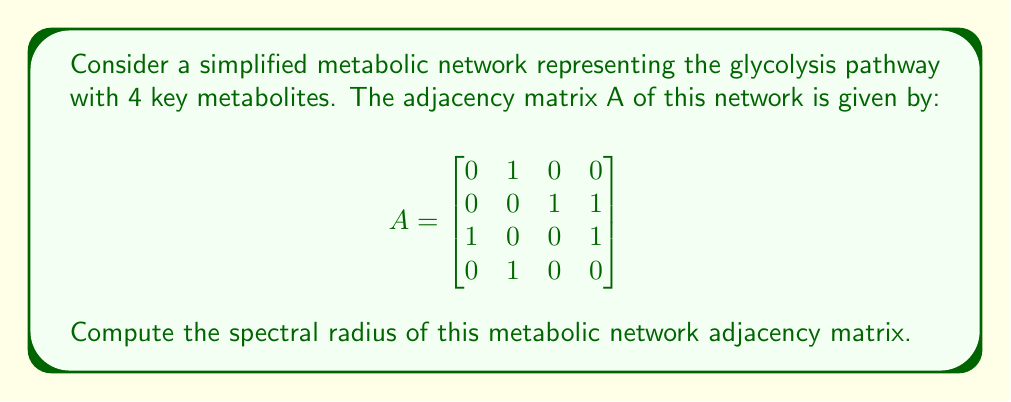Show me your answer to this math problem. To find the spectral radius of the adjacency matrix A, we need to follow these steps:

1) First, calculate the characteristic polynomial of A:
   $$det(A - \lambda I) = \begin{vmatrix}
   -\lambda & 1 & 0 & 0 \\
   0 & -\lambda & 1 & 1 \\
   1 & 0 & -\lambda & 1 \\
   0 & 1 & 0 & -\lambda
   \end{vmatrix}$$

2) Expand the determinant:
   $$\lambda^4 - \lambda^2 - 1 = 0$$

3) This is a fourth-degree polynomial. To solve it, we can substitute $\mu = \lambda^2$:
   $$\mu^2 - \mu - 1 = 0$$

4) This is a quadratic equation in $\mu$. We can solve it using the quadratic formula:
   $$\mu = \frac{1 \pm \sqrt{1^2 + 4(1)}}{2} = \frac{1 \pm \sqrt{5}}{2}$$

5) The positive solution is $\mu = \frac{1 + \sqrt{5}}{2}$, which is the golden ratio $\phi$.

6) Since $\mu = \lambda^2$, we have:
   $$\lambda = \pm \sqrt{\frac{1 + \sqrt{5}}{2}}$$

7) The spectral radius is the largest absolute eigenvalue. Therefore:
   $$\rho(A) = \sqrt{\frac{1 + \sqrt{5}}{2}}$$

This value is approximately 1.27201964951.
Answer: $\sqrt{\frac{1 + \sqrt{5}}{2}}$ 